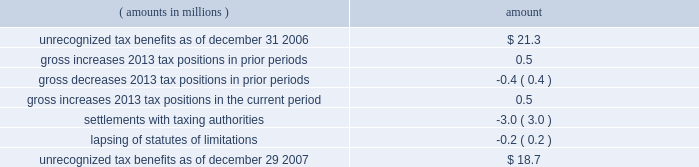Notes to consolidated financial statements ( continued ) | 72 snap-on incorporated following is a reconciliation of the beginning and ending amount of unrecognized tax benefits : ( amounts in millions ) amount .
Of the $ 18.7 million of unrecognized tax benefits at the end of 2007 , approximately $ 16.2 million would impact the effective income tax rate if recognized .
Interest and penalties related to unrecognized tax benefits are recorded in income tax expense .
During the years ended december 29 , 2007 , december 30 , 2006 , and december 31 , 2005 , the company recognized approximately $ 1.2 million , $ 0.5 million and ( $ 0.5 ) million in net interest expense ( benefit ) , respectively .
The company has provided for approximately $ 3.4 million , $ 2.2 million , and $ 1.7 million of accrued interest related to unrecognized tax benefits at the end of fiscal year 2007 , 2006 and 2005 , respectively .
During the next 12 months , the company does not anticipate any significant changes to the total amount of unrecognized tax benefits , other than the accrual of additional interest expense in an amount similar to the prior year 2019s expense .
With few exceptions , snap-on is no longer subject to u.s .
Federal and state/local income tax examinations by tax authorities for years prior to 2003 , and snap-on is no longer subject to non-u.s .
Income tax examinations by tax authorities for years prior to 2001 .
The undistributed earnings of all non-u.s .
Subsidiaries totaled $ 338.5 million , $ 247.4 million and $ 173.6 million at the end of fiscal 2007 , 2006 and 2005 , respectively .
Snap-on has not provided any deferred taxes on these undistributed earnings as it considers the undistributed earnings to be permanently invested .
Determination of the amount of unrecognized deferred income tax liability related to these earnings is not practicable .
The american jobs creation act of 2004 ( the 201cajca 201d ) created a one-time tax incentive for u.s .
Corporations to repatriate accumulated foreign earnings by providing a tax deduction of 85% ( 85 % ) of qualifying dividends received from foreign affiliates .
Under the provisions of the ajca , snap-on repatriated approximately $ 93 million of qualifying dividends in 2005 that resulted in additional income tax expense of $ 3.3 million for the year .
Note 9 : short-term and long-term debt notes payable and long-term debt as of december 29 , 2007 , was $ 517.9 million ; no commercial paper was outstanding at december 29 , 2007 .
As of december 30 , 2006 , notes payable and long-term debt was $ 549.2 million , including $ 314.9 million of commercial paper .
Snap-on presented $ 300 million of the december 30 , 2006 , outstanding commercial paper as 201clong-term debt 201d on the accompanying december 30 , 2006 , consolidated balance sheet .
On january 12 , 2007 , snap-on sold $ 300 million of unsecured notes consisting of $ 150 million of floating rate notes that mature on january 12 , 2010 , and $ 150 million of fixed rate notes that mature on january 15 , 2017 .
Interest on the floating rate notes accrues at a rate equal to the three-month london interbank offer rate plus 0.13% ( 0.13 % ) per year and is payable quarterly .
Interest on the fixed rate notes accrues at a rate of 5.50% ( 5.50 % ) per year and is payable semi-annually .
Snap-on used the proceeds from the sale of the notes , net of $ 1.5 million of transaction costs , to repay commercial paper obligations issued to finance the acquisition of business solutions .
On january 12 , 2007 , the company also terminated a $ 250 million bridge credit agreement that snap-on established prior to its acquisition of business solutions. .
What are the total earnings generated by non-us subsidiaries in the last three years? 
Computations: ((338.5 + 247.4) + 173.6)
Answer: 759.5. 